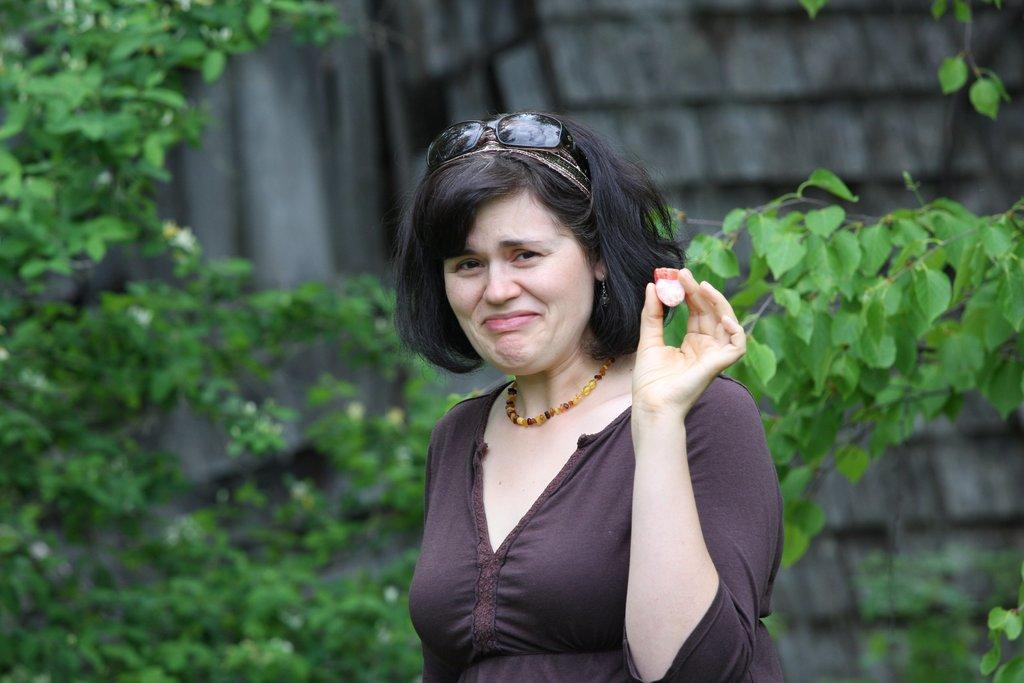Who is present in the image? There is a woman in the image. What is the woman holding in the image? The woman is holding an object. Can you describe the woman's appearance? The woman is wearing glasses. What can be seen in the background of the image? There are leaves visible in the background of the image. What type of feeling does the locket in the image represent? There is no locket present in the image, so it is not possible to determine what feeling it might represent. 